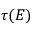Convert formula to latex. <formula><loc_0><loc_0><loc_500><loc_500>\tau ( E )</formula> 